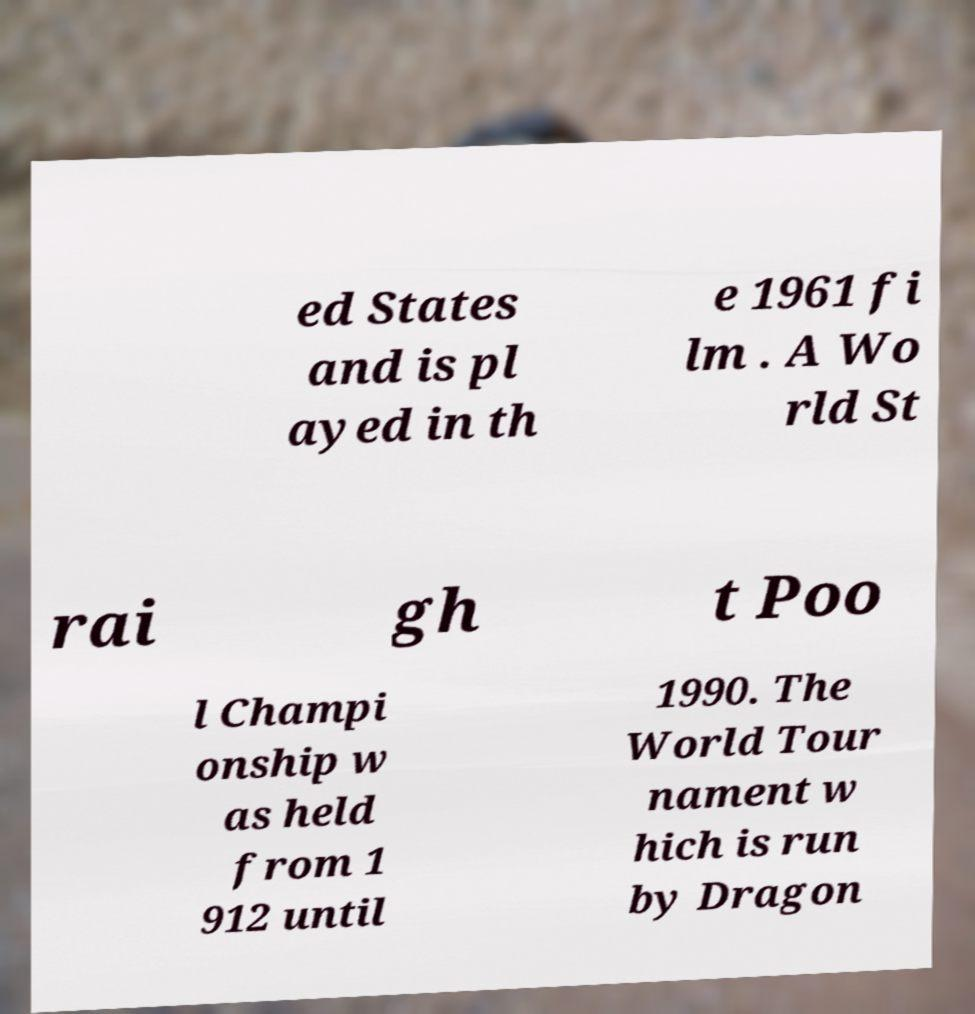Could you assist in decoding the text presented in this image and type it out clearly? ed States and is pl ayed in th e 1961 fi lm . A Wo rld St rai gh t Poo l Champi onship w as held from 1 912 until 1990. The World Tour nament w hich is run by Dragon 